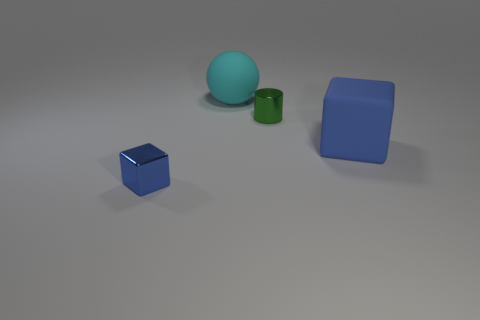Can you describe the setting of this image? Certainly! The image depicts a simple scene with a selection of objects arranged on what appears to be a smooth matte surface. There is a small blue cube, a green cylinder, a larger blue cube, and an even larger cyan sphere. The lighting suggests an indoor setting with a soft and diffuse source, possibly striving for a minimalistic or procedural demonstration. 